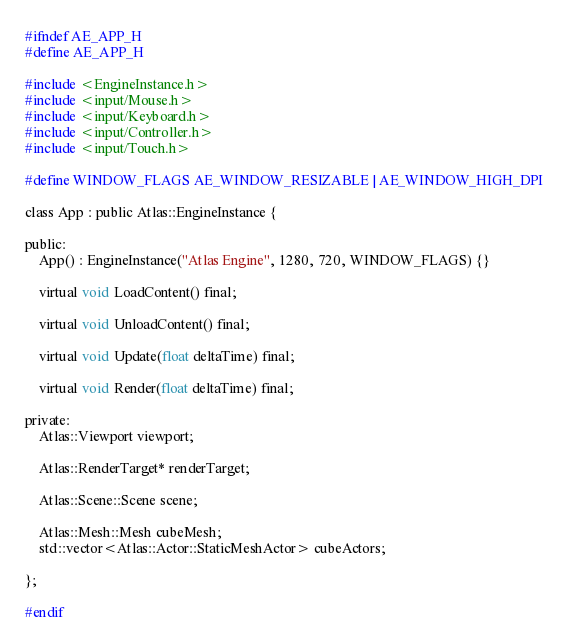<code> <loc_0><loc_0><loc_500><loc_500><_C_>#ifndef AE_APP_H
#define AE_APP_H

#include <EngineInstance.h>
#include <input/Mouse.h>
#include <input/Keyboard.h>
#include <input/Controller.h>
#include <input/Touch.h>

#define WINDOW_FLAGS AE_WINDOW_RESIZABLE | AE_WINDOW_HIGH_DPI

class App : public Atlas::EngineInstance {

public:
	App() : EngineInstance("Atlas Engine", 1280, 720, WINDOW_FLAGS) {}

	virtual void LoadContent() final;

	virtual void UnloadContent() final;

	virtual void Update(float deltaTime) final;

	virtual void Render(float deltaTime) final;

private:
    Atlas::Viewport viewport;

    Atlas::RenderTarget* renderTarget;

    Atlas::Scene::Scene scene;

    Atlas::Mesh::Mesh cubeMesh;
    std::vector<Atlas::Actor::StaticMeshActor> cubeActors;

};

#endif</code> 